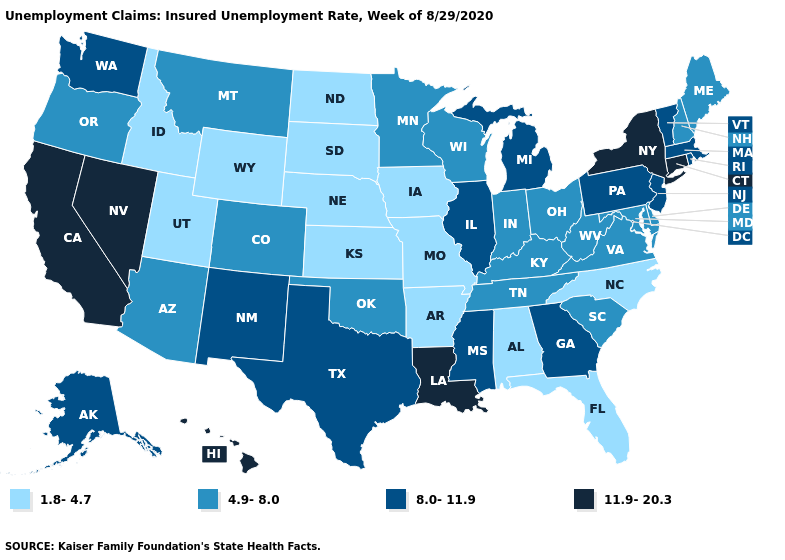What is the value of Louisiana?
Keep it brief. 11.9-20.3. Name the states that have a value in the range 11.9-20.3?
Short answer required. California, Connecticut, Hawaii, Louisiana, Nevada, New York. What is the highest value in states that border Colorado?
Write a very short answer. 8.0-11.9. What is the value of Nevada?
Write a very short answer. 11.9-20.3. What is the lowest value in the West?
Write a very short answer. 1.8-4.7. What is the highest value in the South ?
Give a very brief answer. 11.9-20.3. Does Louisiana have a higher value than Kansas?
Concise answer only. Yes. What is the highest value in the West ?
Short answer required. 11.9-20.3. Among the states that border North Dakota , which have the lowest value?
Quick response, please. South Dakota. What is the value of West Virginia?
Give a very brief answer. 4.9-8.0. Which states have the lowest value in the Northeast?
Give a very brief answer. Maine, New Hampshire. Does New York have the highest value in the USA?
Short answer required. Yes. Which states have the lowest value in the South?
Short answer required. Alabama, Arkansas, Florida, North Carolina. What is the value of Alaska?
Be succinct. 8.0-11.9. 